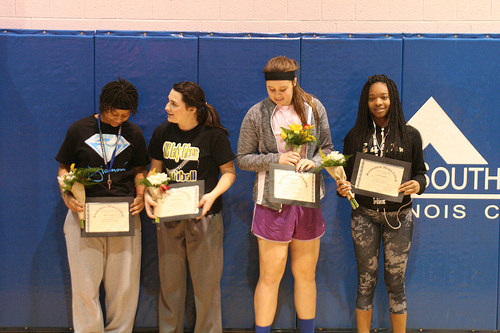<image>
Can you confirm if the woman is behind the flower? Yes. From this viewpoint, the woman is positioned behind the flower, with the flower partially or fully occluding the woman. Is there a award in front of the girl? No. The award is not in front of the girl. The spatial positioning shows a different relationship between these objects. 